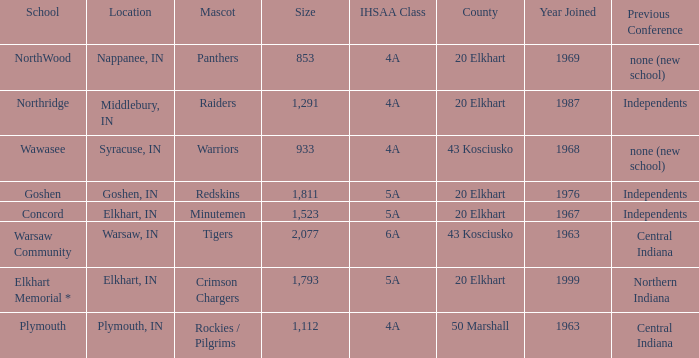What is the size of the team that was previously from Central Indiana conference, and is in IHSSA Class 4a? 1112.0. 